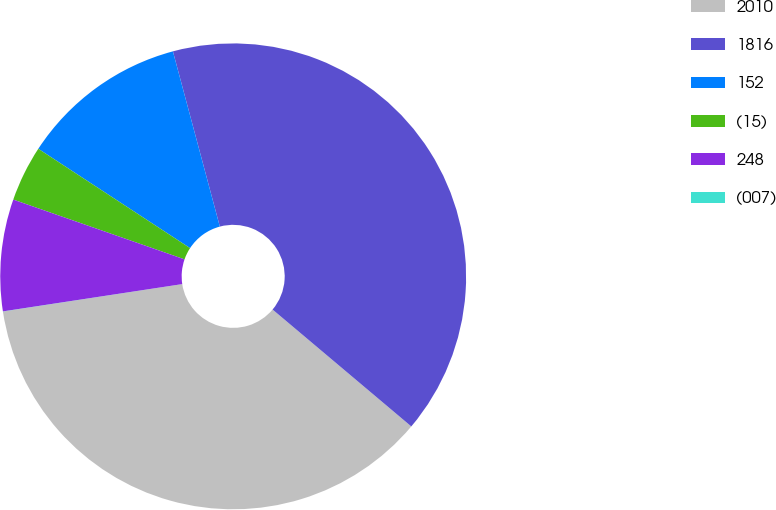<chart> <loc_0><loc_0><loc_500><loc_500><pie_chart><fcel>2010<fcel>1816<fcel>152<fcel>(15)<fcel>248<fcel>(007)<nl><fcel>36.44%<fcel>40.31%<fcel>11.61%<fcel>3.88%<fcel>7.75%<fcel>0.01%<nl></chart> 